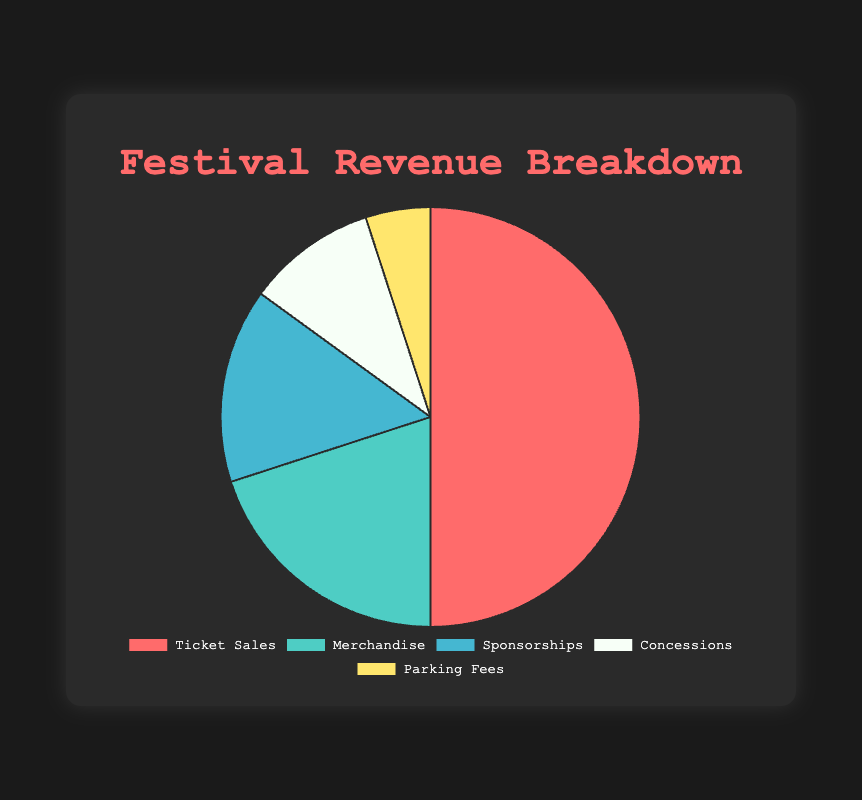Which source contributes the most to the festival's revenue? The slice representing "Ticket Sales" is the largest portion of the pie chart, indicating it contributes the most to the festival's revenue.
Answer: Ticket Sales Which two sources combined contribute exactly half of the total revenue? The sources "Ticket Sales" (50%) and "Merchandise" (20%) combined contribute 70%, which makes up more than half. Thus, it's not valid for this condition. Instead, checking if a combination of any two other values sums up to 50%: "Sponsorships" (15%) + "Concessions" (10%) + "Parking Fees" (5%) doesn't add to 50%. Hence the only valid combination is "Sponsorships" (15%) and "Concessions" (10%) adding up to exactly 25%, so there isn't a valid combination that adds up to exactly half according to the provided data.
Answer: None Which source has the smallest contribution to the festival's revenue? The smallest segment on the pie chart corresponds to "Parking Fees," which contributes 5%.
Answer: Parking Fees Is the contribution from Sponsorships greater than from Concessions? If so, by how much? From the pie chart, "Sponsorships" is shown at 15%, and "Concessions" at 10%. Subtracting, 15% - 10% = 5%. Hence, the contribution from Sponsorships is greater by 5%.
Answer: Yes, by 5% What percentage of the revenue comes from non-ticket sources? Summing the percentages of all non-ticket sources: 20% (Merchandise) + 15% (Sponsorships) + 10% (Concessions) + 5% (Parking Fees) = 50%.
Answer: 50% If the total revenue was $200,000, how much revenue came from Merchandise? The Merchandise section is 20% of the total revenue. Calculating 20% of $200,000: (20/100) * $200,000 = $40,000
Answer: $40,000 Which source is represented by the light green color in the pie chart? The legend in the pie chart indicates "Merchandise" is represented by the light green color.
Answer: Merchandise Is the contribution from Merchandise and Concessions together more significant than that from Sponsorships? Adding the contributions from Merchandise (20%) and Concessions (10%) gives 30%, which is more than Sponsorships' 15%.
Answer: Yes What is the visual relationship between the segment sizes for Ticket Sales and Parking Fees? Visually, the segment representing Ticket Sales is considerably larger than the Parking Fees segment, indicating Ticket Sales have a much higher revenue contribution than Parking Fees.
Answer: Ticket Sales segment is much larger than Parking Fees segment 